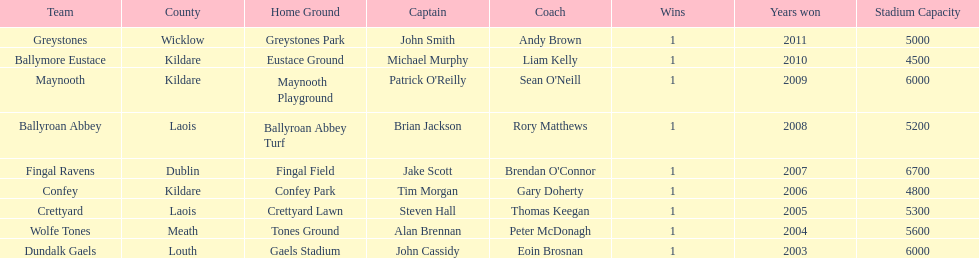What is the years won for each team 2011, 2010, 2009, 2008, 2007, 2006, 2005, 2004, 2003. 